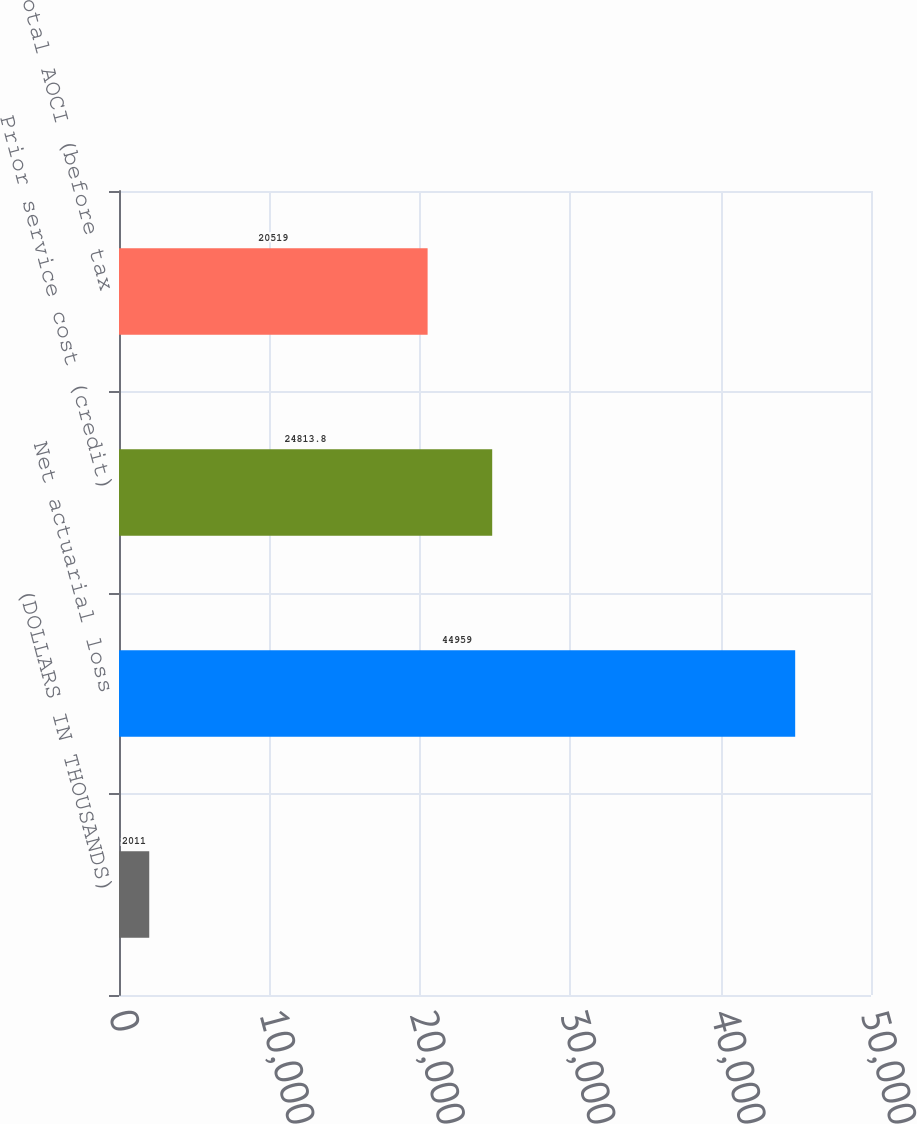<chart> <loc_0><loc_0><loc_500><loc_500><bar_chart><fcel>(DOLLARS IN THOUSANDS)<fcel>Net actuarial loss<fcel>Prior service cost (credit)<fcel>Total AOCI (before tax<nl><fcel>2011<fcel>44959<fcel>24813.8<fcel>20519<nl></chart> 